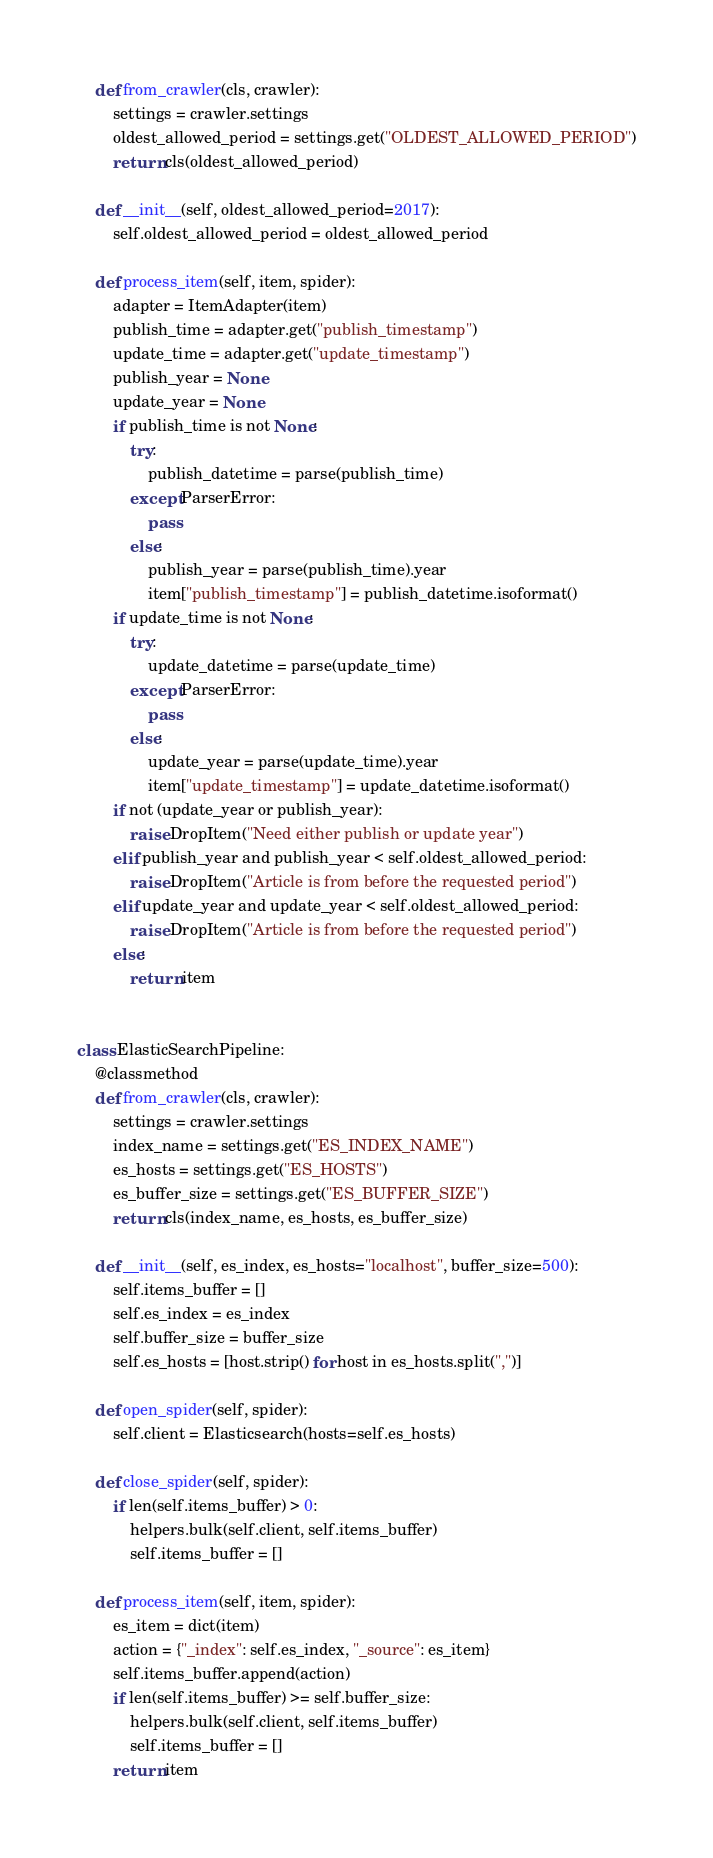Convert code to text. <code><loc_0><loc_0><loc_500><loc_500><_Python_>    def from_crawler(cls, crawler):
        settings = crawler.settings
        oldest_allowed_period = settings.get("OLDEST_ALLOWED_PERIOD")
        return cls(oldest_allowed_period)

    def __init__(self, oldest_allowed_period=2017):
        self.oldest_allowed_period = oldest_allowed_period

    def process_item(self, item, spider):
        adapter = ItemAdapter(item)
        publish_time = adapter.get("publish_timestamp")
        update_time = adapter.get("update_timestamp")
        publish_year = None
        update_year = None
        if publish_time is not None:
            try:
                publish_datetime = parse(publish_time)
            except ParserError:
                pass
            else:
                publish_year = parse(publish_time).year
                item["publish_timestamp"] = publish_datetime.isoformat()
        if update_time is not None:
            try:
                update_datetime = parse(update_time)
            except ParserError:
                pass
            else:
                update_year = parse(update_time).year
                item["update_timestamp"] = update_datetime.isoformat()
        if not (update_year or publish_year):
            raise DropItem("Need either publish or update year")
        elif publish_year and publish_year < self.oldest_allowed_period:
            raise DropItem("Article is from before the requested period")
        elif update_year and update_year < self.oldest_allowed_period:
            raise DropItem("Article is from before the requested period")
        else:
            return item


class ElasticSearchPipeline:
    @classmethod
    def from_crawler(cls, crawler):
        settings = crawler.settings
        index_name = settings.get("ES_INDEX_NAME")
        es_hosts = settings.get("ES_HOSTS")
        es_buffer_size = settings.get("ES_BUFFER_SIZE")
        return cls(index_name, es_hosts, es_buffer_size)

    def __init__(self, es_index, es_hosts="localhost", buffer_size=500):
        self.items_buffer = []
        self.es_index = es_index
        self.buffer_size = buffer_size
        self.es_hosts = [host.strip() for host in es_hosts.split(",")]

    def open_spider(self, spider):
        self.client = Elasticsearch(hosts=self.es_hosts)

    def close_spider(self, spider):
        if len(self.items_buffer) > 0:
            helpers.bulk(self.client, self.items_buffer)
            self.items_buffer = []

    def process_item(self, item, spider):
        es_item = dict(item)
        action = {"_index": self.es_index, "_source": es_item}
        self.items_buffer.append(action)
        if len(self.items_buffer) >= self.buffer_size:
            helpers.bulk(self.client, self.items_buffer)
            self.items_buffer = []
        return item
</code> 